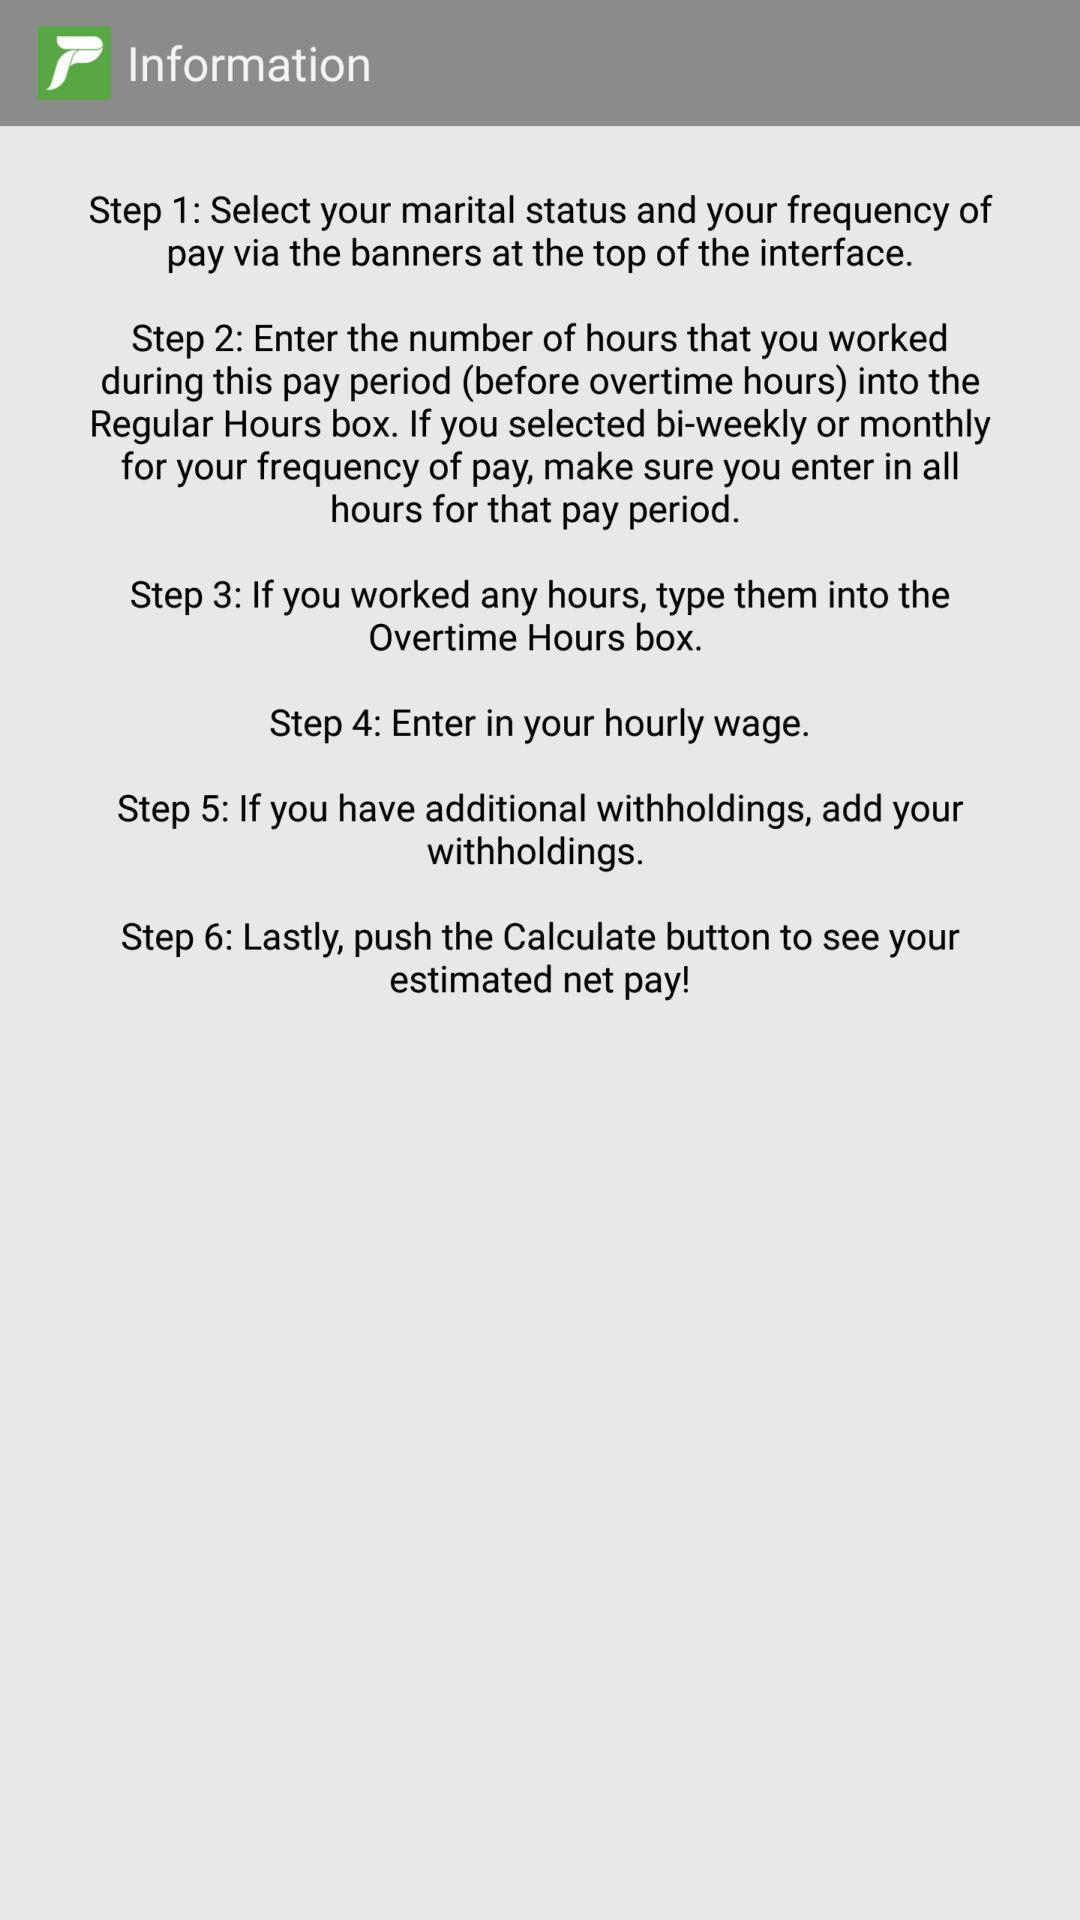How many steps are there in the process?
Answer the question using a single word or phrase. 6 